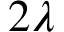Convert formula to latex. <formula><loc_0><loc_0><loc_500><loc_500>2 \lambda</formula> 